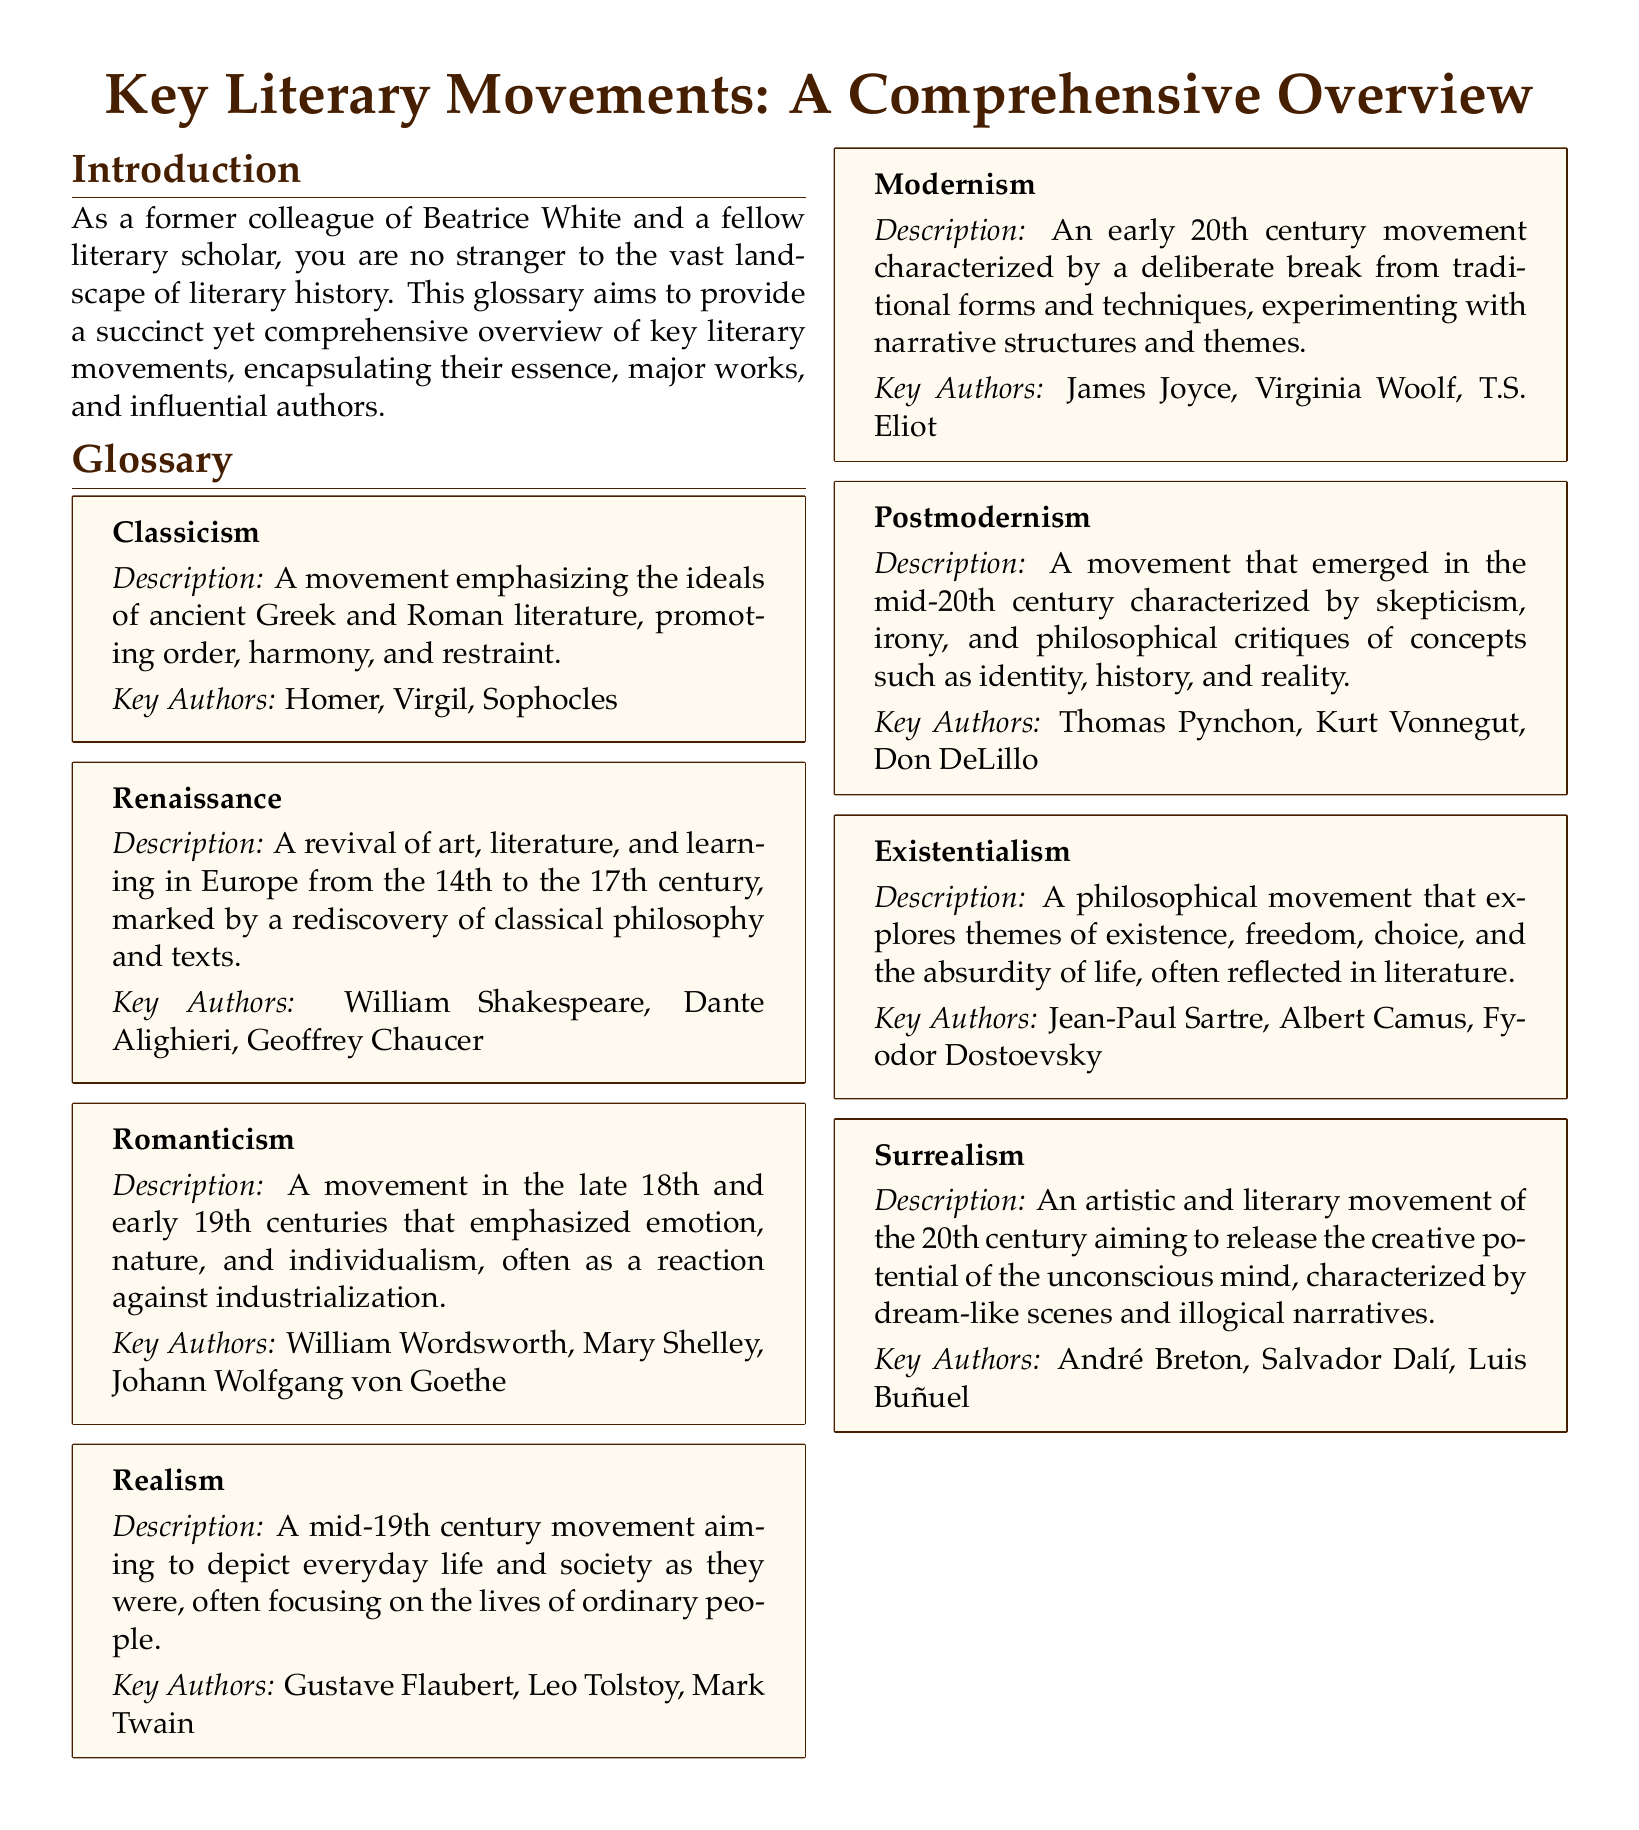What is the title of the document? The title is presented prominently at the beginning of the document.
Answer: Key Literary Movements: A Comprehensive Overview Which literary movement is associated with the author William Wordsworth? The document lists key authors under each movement, revealing their association.
Answer: Romanticism What does the movement Classicism emphasize? The description in the entry summarizes the main focus of this movement.
Answer: Order, harmony, and restraint Who is a key author of Modernism? The entry for Modernism lists this author among others, highlighting their significance.
Answer: James Joyce What period does the Renaissance movement cover? The introduction specifies the timeline of this literary period.
Answer: 14th to the 17th century Which literary movement aims to depict everyday life and society? The glossary entry for Realism describes its primary objective.
Answer: Realism Name a key feature of Surrealism. The description outlines the characteristics that define this artistic movement.
Answer: Dream-like scenes What is a common theme explored in Existentialism? The entry provides insight into the thematic focus of this philosophical movement.
Answer: Existence Which literary movement emerged in the mid-20th century? The description points to a specific time frame for this movement.
Answer: Postmodernism 